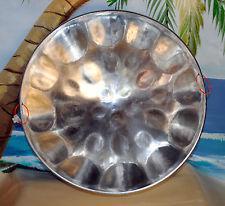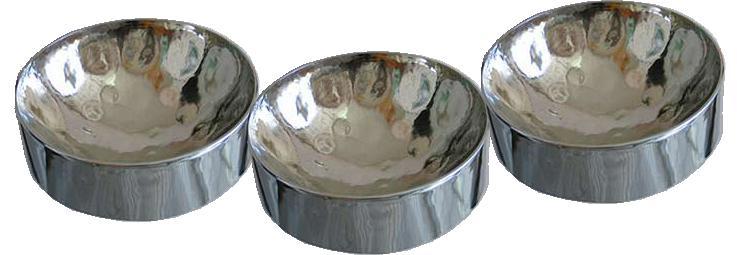The first image is the image on the left, the second image is the image on the right. Evaluate the accuracy of this statement regarding the images: "In exactly one image someone is playing steel drums.". Is it true? Answer yes or no. No. The first image is the image on the left, the second image is the image on the right. Given the left and right images, does the statement "One image features at least one steel drum with a concave hammered-look bowl, and the other image shows one person holding two drum sticks inside one drum's bowl." hold true? Answer yes or no. No. 